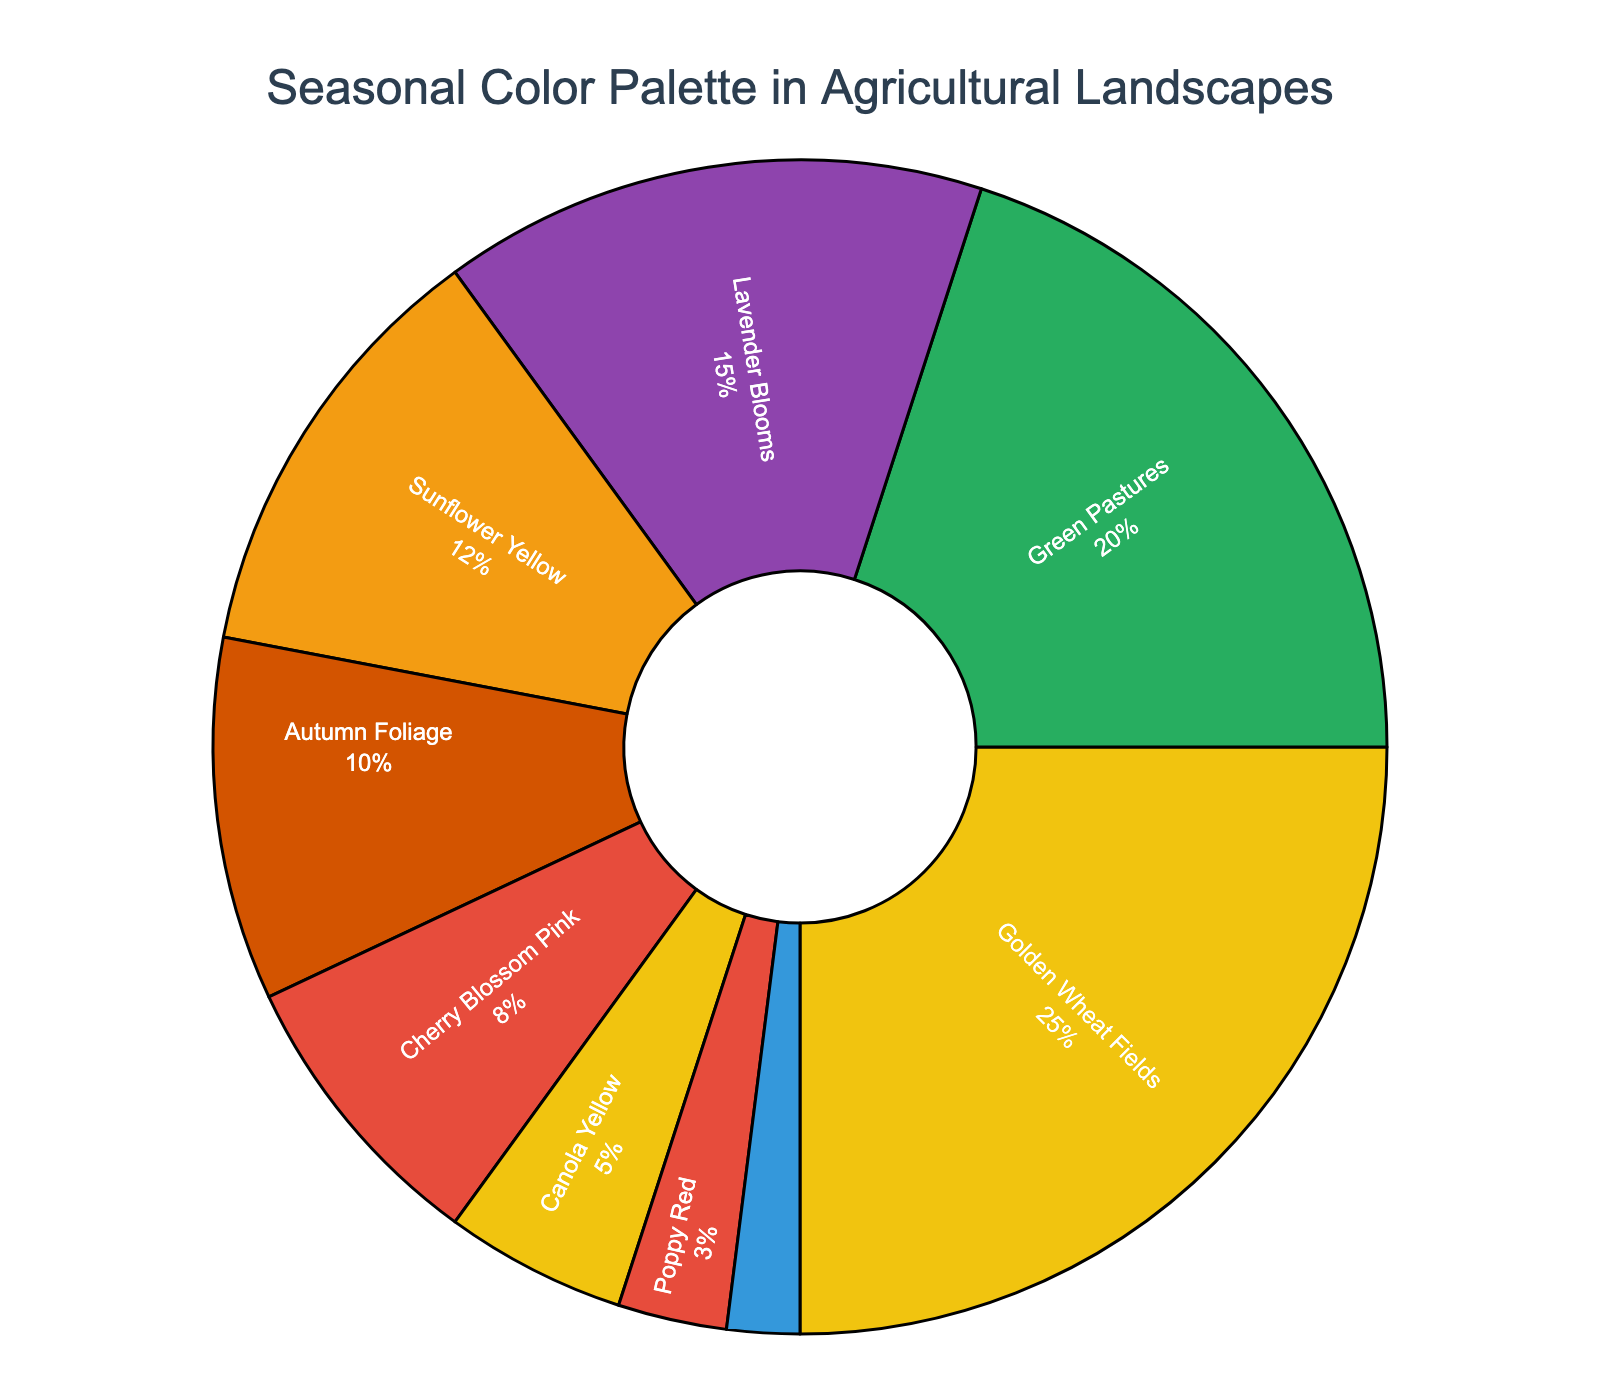Which season has the highest representation in the color palette? The season with the highest representation will have the largest percentage shown in the pie chart. According to the data, Golden Wheat Fields have the highest percentage at 25%.
Answer: Golden Wheat Fields Which two seasons together make up the same percentage as Green Pastures? Green Pastures have a percentage of 20%. Looking at the pie chart, Cherry Blossom Pink (8%) and Canola Yellow (5%) and Poppy Red (3%) together add up to the same percentage (8 + 5 + 3 = 16).
Answer: Cherry Blossom Pink, Canola Yellow, and Poppy Red How does the representation of Lavender Blooms compare to that of Sunflower Yellow? The percentage for Lavender Blooms is 15%, whereas Sunflower Yellow is 12%. Lavender Blooms has a larger percentage than Sunflower Yellow.
Answer: Lavender Blooms is greater than Sunflower Yellow What is the total percentage of seasons that have less than 10% representation? Adding the percentages of the seasons with less than 10% representation: Autumn Foliage (10%), Cherry Blossom Pink (8%), Canola Yellow (5%), Poppy Red (3%), and Cornflower Blue (2%). Total percentage is 10 + 8 + 5 + 3 + 2 = 28%.
Answer: 28% Which season is represented by a green color in the chart? By looking at the pie chart, the segment representing green color corresponds to Green Pastures, which is also logically coherent with the name.
Answer: Green Pastures What's the difference in percentage between the season with the highest and the lowest representation in the chart? Golden Wheat Fields (highest) have 25% and Cornflower Blue (lowest) have 2%. The difference is 25 - 2 = 23%.
Answer: 23% If you combine all seasons with more than 10% representation, what percentage do they cover? Combine Golden Wheat Fields (25%), Green Pastures (20%), Lavender Blooms (15%), and Sunflower Yellow (12%). The combined percentage is 25 + 20 + 15 + 12 = 72%.
Answer: 72% Which season has a visual representation closest to 10% in the chart? Quick visual estimation and reading from the chart, Autumn Foliage has a 10% representation, which is closest to this value.
Answer: Autumn Foliage How do the combined representations of Lavender Blooms and Autumn Foliage compare to that of Golden Wheat Fields? Lavender Blooms (15%) and Autumn Foliage (10%) together make 15 + 10 = 25%, which is the same as Golden Wheat Fields.
Answer: Equal 